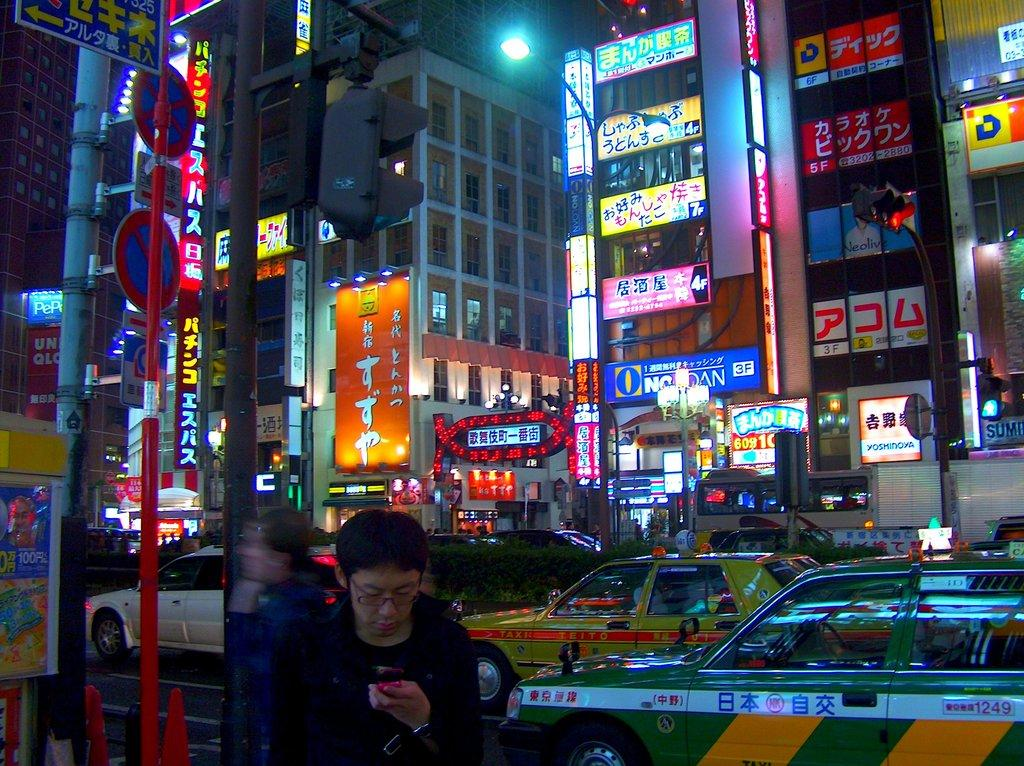<image>
Relay a brief, clear account of the picture shown. A man with glasses is looking at his phone and a busy intersection is behind him with a taxi that has the number 1249 on the side. 